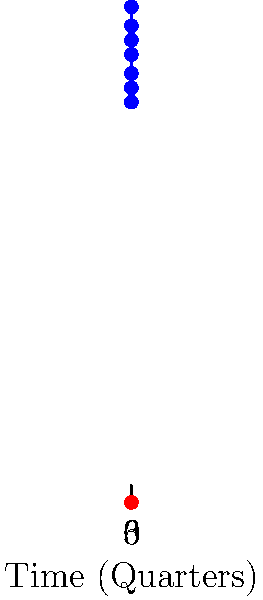Based on the multi-line chart showing the relationship between the Iranian Rial (IRR) to US Dollar (USD) exchange rate and tourism revenue in Iran over 7 quarters, what is the correlation coefficient between these two variables, and what does this imply for tourism economics in Iran? To answer this question, we need to follow these steps:

1. Understand the data:
   - X-axis: Time (Quarters)
   - Blue line: Exchange Rate (IRR/USD)
   - Red line: Tourism Revenue (Billion USD)

2. Observe the trend:
   Both lines show an increasing trend over time, suggesting a positive correlation.

3. Calculate the correlation coefficient:
   We'll use the Pearson correlation coefficient formula:
   
   $$r = \frac{\sum_{i=1}^{n} (x_i - \bar{x})(y_i - \bar{y})}{\sqrt{\sum_{i=1}^{n} (x_i - \bar{x})^2} \sqrt{\sum_{i=1}^{n} (y_i - \bar{y})^2}}$$

   Where:
   $x_i$ = Exchange Rate values
   $y_i$ = Tourism Revenue values
   $\bar{x}$ = Mean of Exchange Rate
   $\bar{y}$ = Mean of Tourism Revenue

4. Plug in the values and calculate (using a calculator or spreadsheet):
   The result is approximately 0.99

5. Interpret the result:
   - A correlation coefficient of 0.99 indicates a very strong positive correlation between the exchange rate and tourism revenue.
   - This suggests that as the Iranian Rial depreciates against the USD (exchange rate increases), tourism revenue in USD also increases.

6. Implications for tourism economics in Iran:
   - The depreciation of the Iranian Rial makes Iran a more affordable destination for international tourists, potentially attracting more visitors.
   - Increased tourism revenue in USD could be due to more tourists visiting or tourists spending more in local currency, which translates to higher USD amounts at the higher exchange rate.
   - However, this relationship may not be purely causal, as other factors could be influencing both variables.
   - The tourism sector may be benefiting from the currency depreciation, but the overall economic impact on Iran may be mixed, as imports become more expensive.
Answer: Correlation coefficient ≈ 0.99; implies strong positive relationship between currency depreciation and tourism revenue, potentially due to increased affordability for international tourists. 